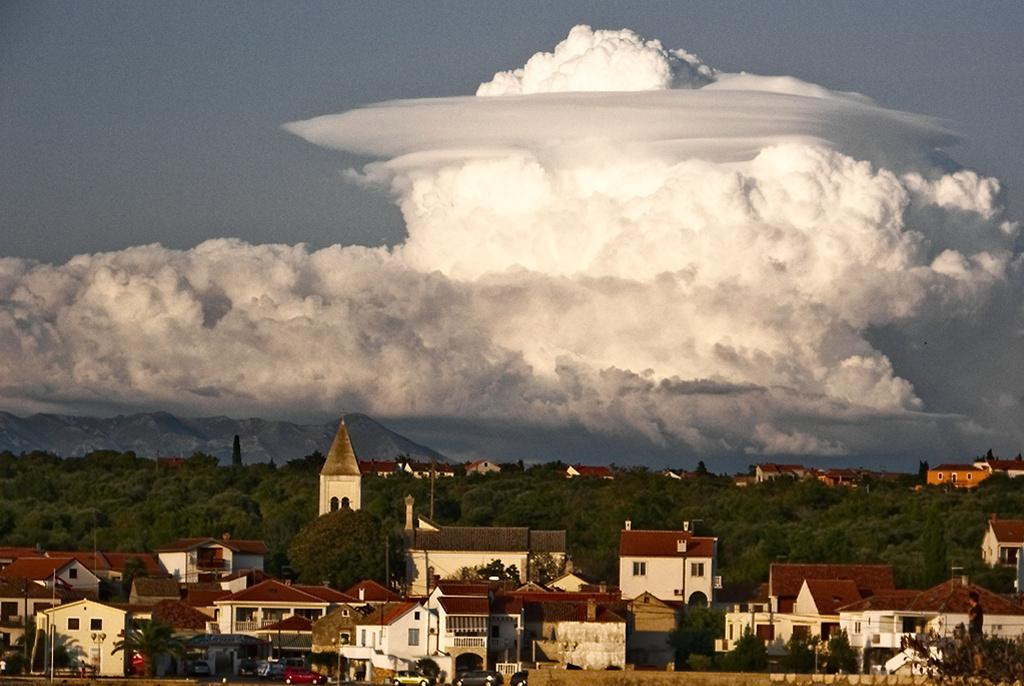What type of structures can be seen in the image? There are buildings in the image. What else can be seen moving in the image? There are vehicles in the image. What type of natural elements are present in the image? There are trees and mountains in the image. What are the vertical structures in the image used for? There are poles in the image, which are likely used for supporting wires or signs. Can you describe the person in the image? There is a person in the image, but their specific appearance or actions are not mentioned in the facts. What is visible in the background of the image? The sky is visible in the background of the image. What type of cream is being used by the person in the image? There is no mention of cream or any specific action being performed by the person in the image. How does the soap in the image contribute to the scene? There is no soap present in the image. 